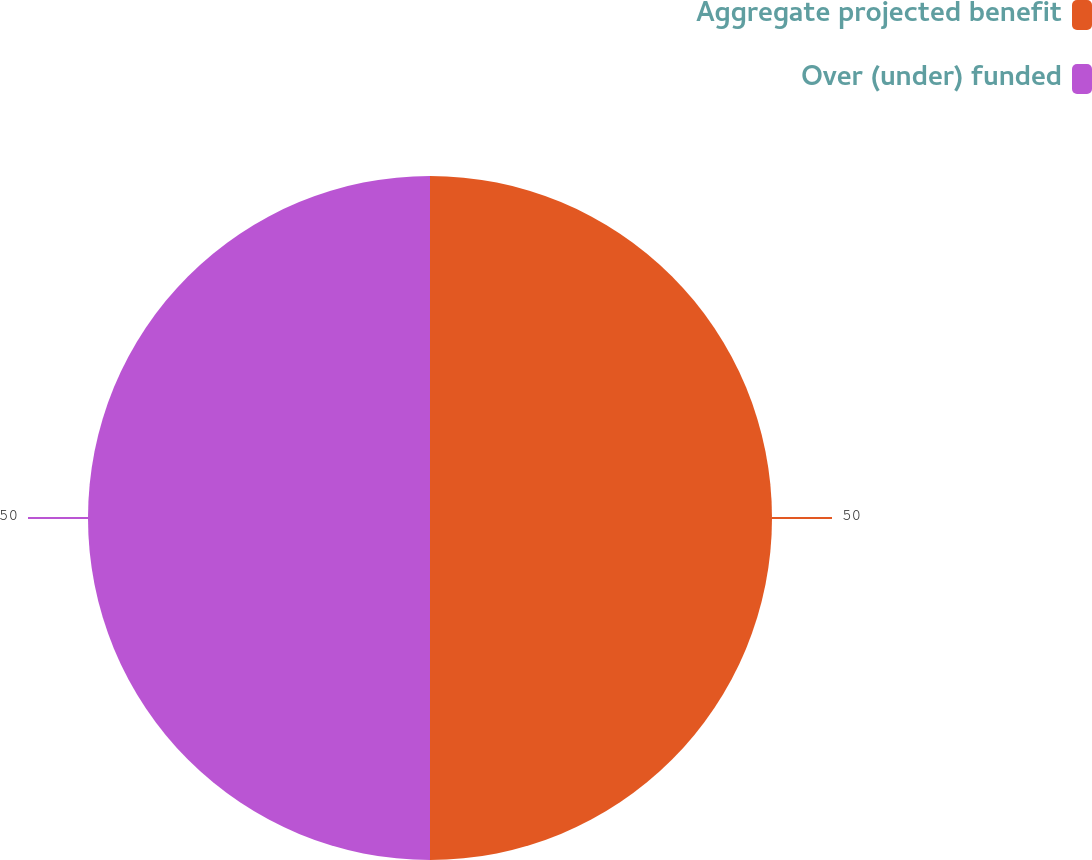<chart> <loc_0><loc_0><loc_500><loc_500><pie_chart><fcel>Aggregate projected benefit<fcel>Over (under) funded<nl><fcel>50.0%<fcel>50.0%<nl></chart> 